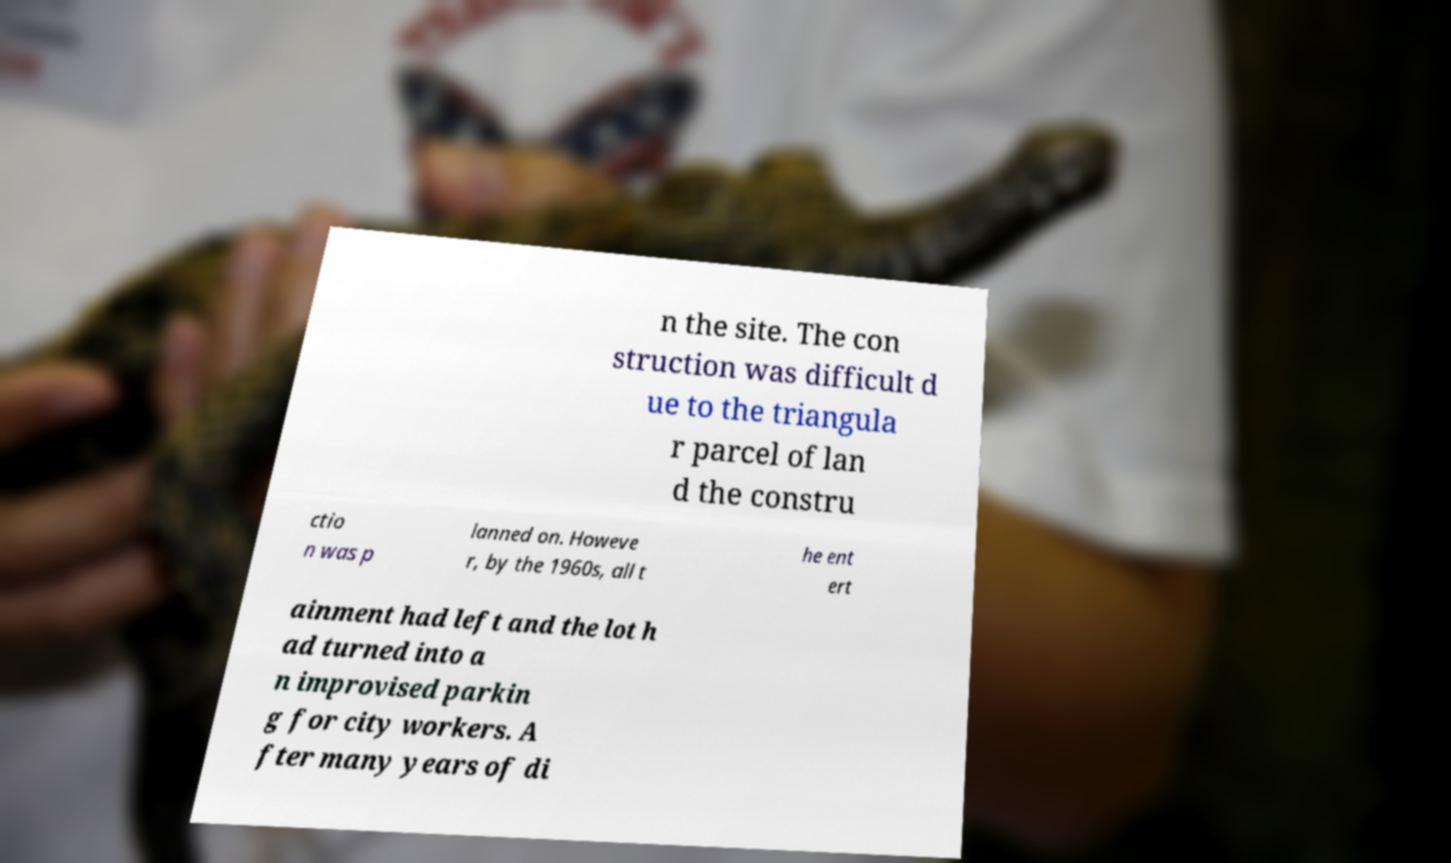Could you extract and type out the text from this image? n the site. The con struction was difficult d ue to the triangula r parcel of lan d the constru ctio n was p lanned on. Howeve r, by the 1960s, all t he ent ert ainment had left and the lot h ad turned into a n improvised parkin g for city workers. A fter many years of di 